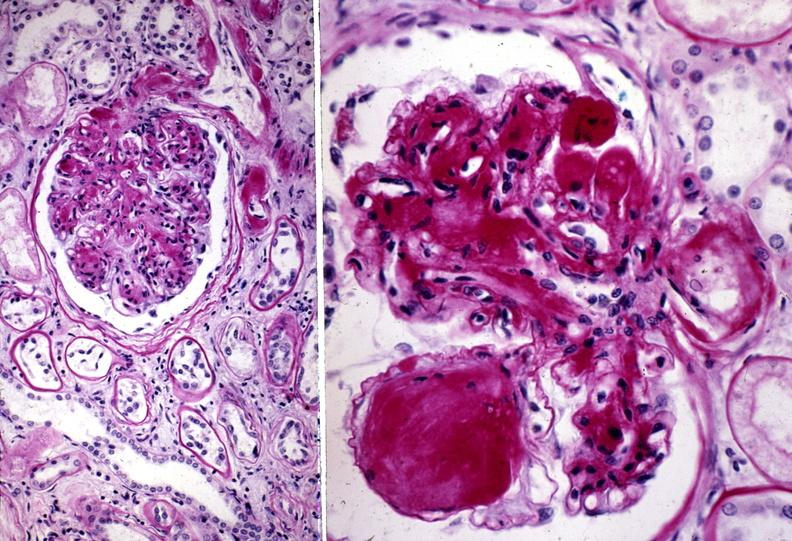what does this image show?
Answer the question using a single word or phrase. Kidney 